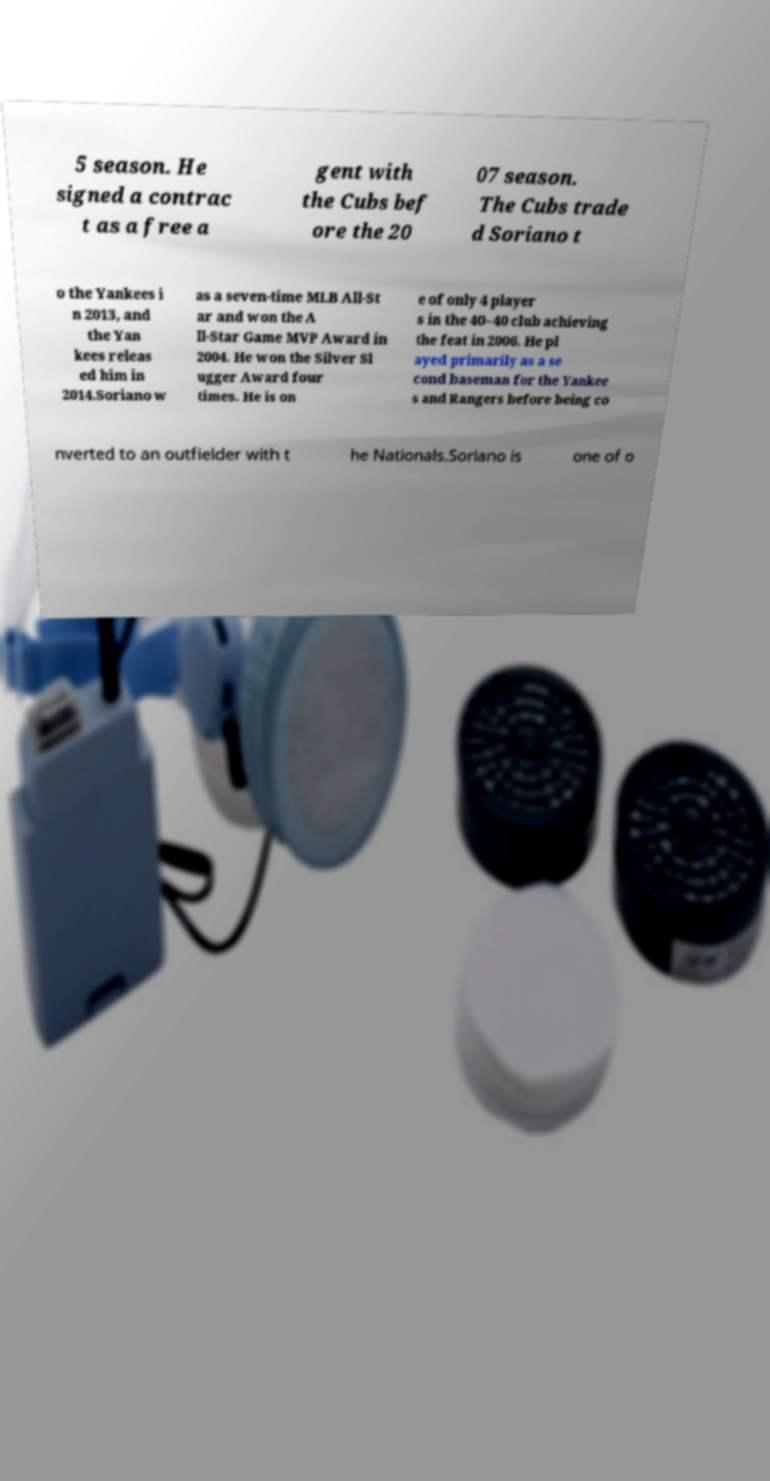For documentation purposes, I need the text within this image transcribed. Could you provide that? 5 season. He signed a contrac t as a free a gent with the Cubs bef ore the 20 07 season. The Cubs trade d Soriano t o the Yankees i n 2013, and the Yan kees releas ed him in 2014.Soriano w as a seven-time MLB All-St ar and won the A ll-Star Game MVP Award in 2004. He won the Silver Sl ugger Award four times. He is on e of only 4 player s in the 40–40 club achieving the feat in 2006. He pl ayed primarily as a se cond baseman for the Yankee s and Rangers before being co nverted to an outfielder with t he Nationals.Soriano is one of o 